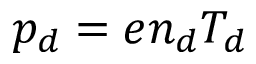<formula> <loc_0><loc_0><loc_500><loc_500>p _ { d } = e n _ { d } T _ { d }</formula> 